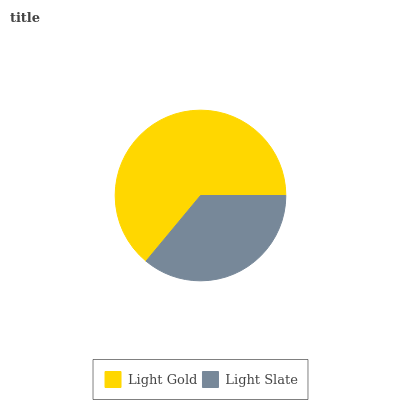Is Light Slate the minimum?
Answer yes or no. Yes. Is Light Gold the maximum?
Answer yes or no. Yes. Is Light Slate the maximum?
Answer yes or no. No. Is Light Gold greater than Light Slate?
Answer yes or no. Yes. Is Light Slate less than Light Gold?
Answer yes or no. Yes. Is Light Slate greater than Light Gold?
Answer yes or no. No. Is Light Gold less than Light Slate?
Answer yes or no. No. Is Light Gold the high median?
Answer yes or no. Yes. Is Light Slate the low median?
Answer yes or no. Yes. Is Light Slate the high median?
Answer yes or no. No. Is Light Gold the low median?
Answer yes or no. No. 